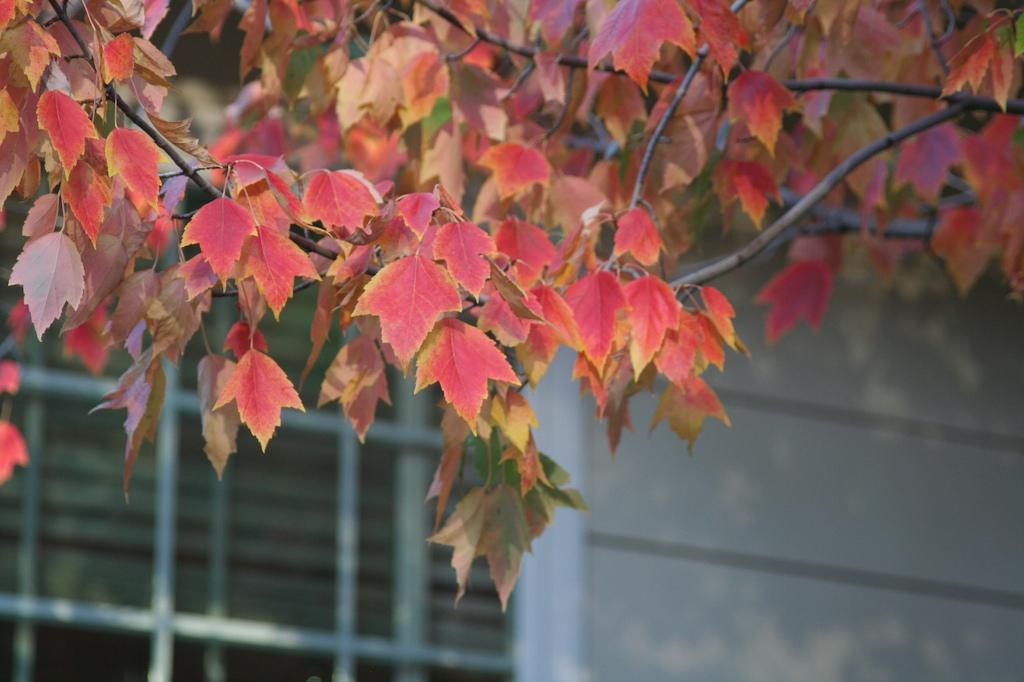Where was the image taken? The image was taken outdoors. What can be seen in the background of the image? There is a building with a wall in the background. What type of plant is visible at the top of the image? There is a tree with leaves, stems, and branches at the top of the image. Is the girl who lives next door visible in the image? There is no girl visible in the image. Does the image provide evidence of the existence of unicorns? The image does not show any unicorns, so it cannot provide evidence of their existence. 